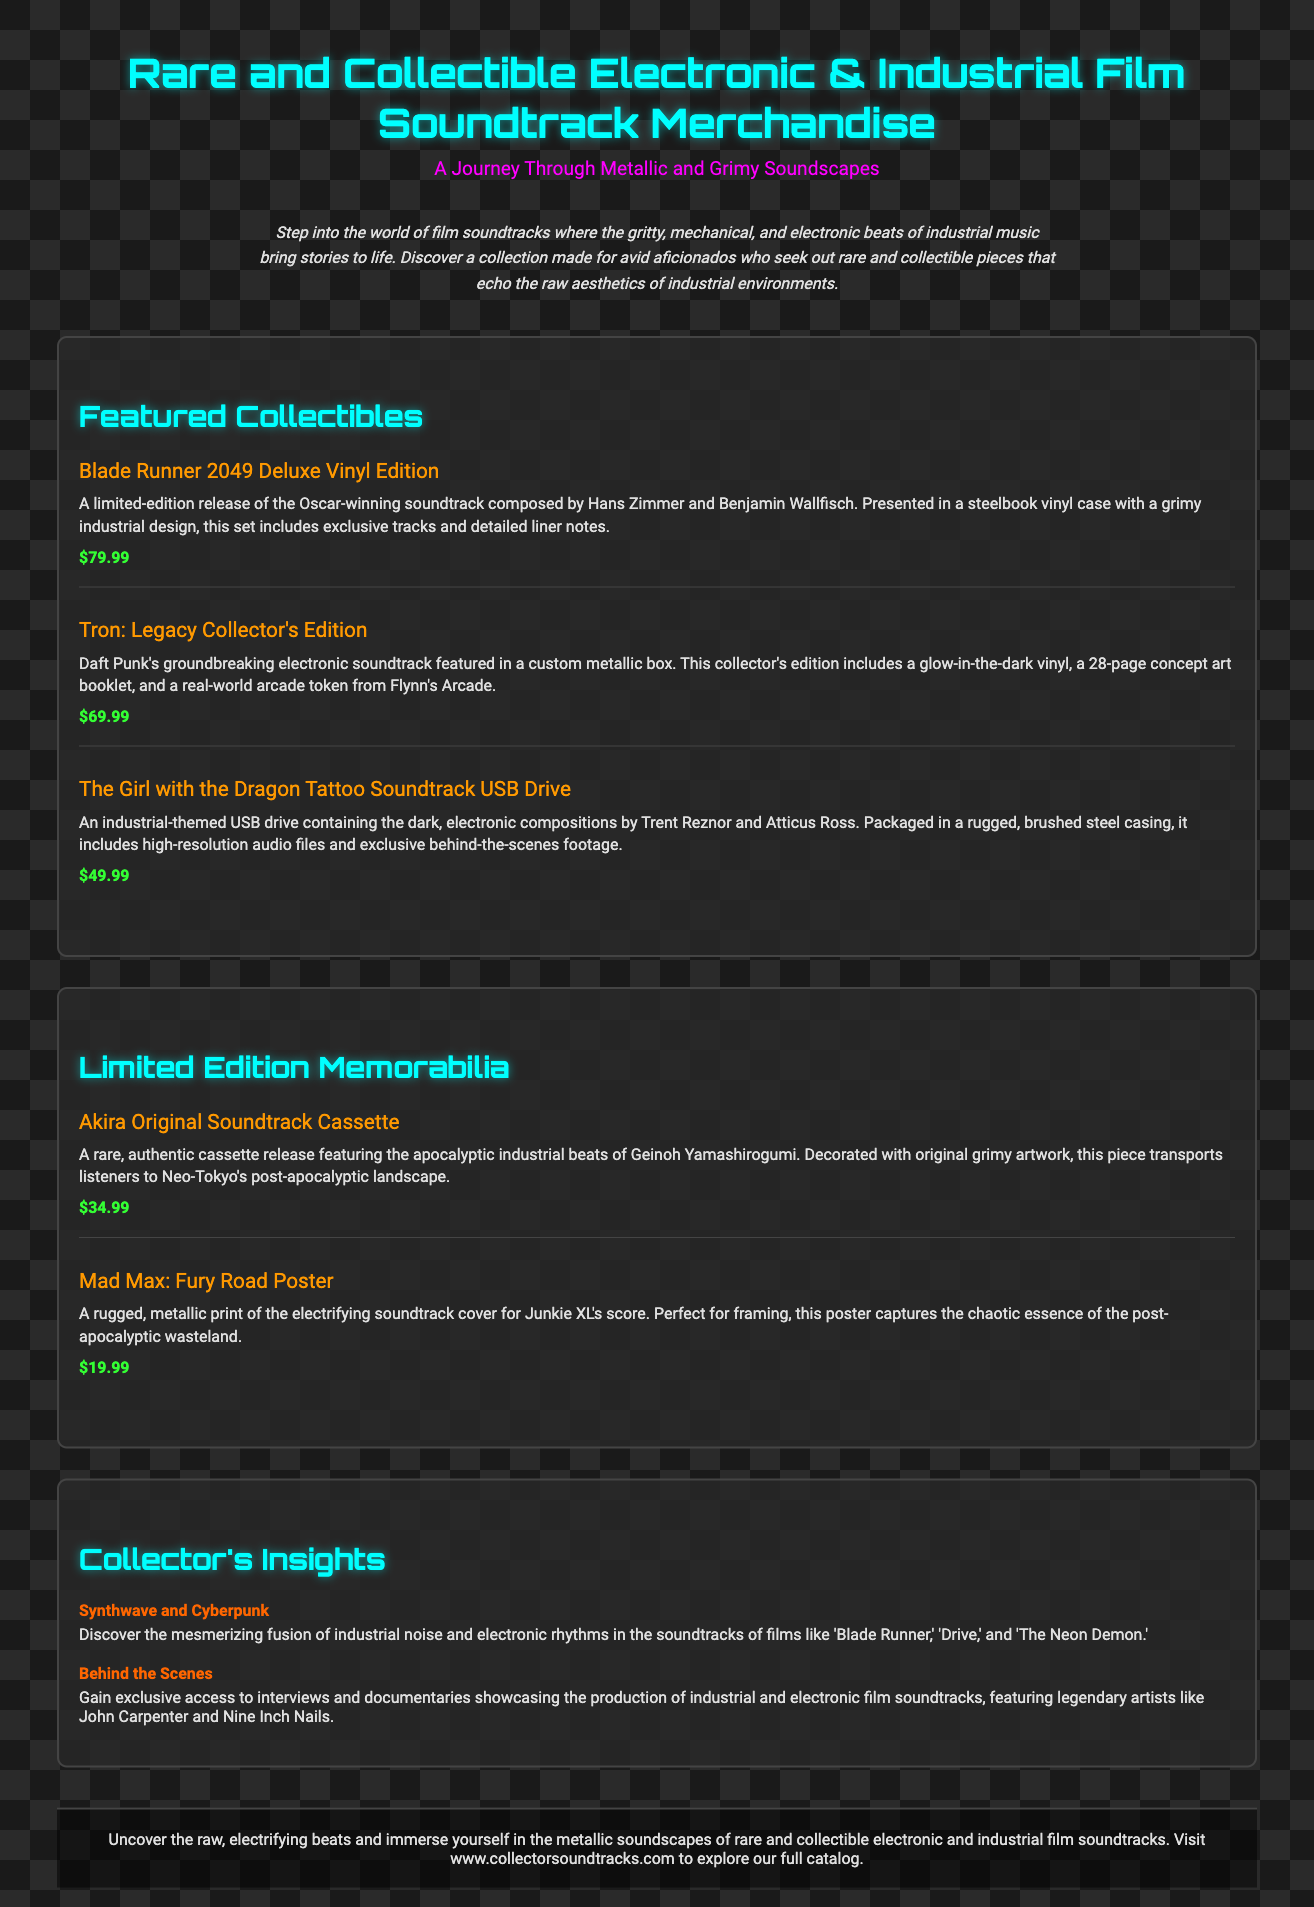what is the title of the first item in Featured Collectibles? The title of the first item listed under Featured Collectibles is found in the item name.
Answer: Blade Runner 2049 Deluxe Vinyl Edition what is the price of The Girl with the Dragon Tattoo Soundtrack USB Drive? The price is stated directly under its description in the document.
Answer: $49.99 how many items are listed in the Limited Edition Memorabilia section? The number of items can be counted from the listings under that section.
Answer: 2 who composed the soundtrack for Tron: Legacy? The composer of the soundtrack is mentioned in the item's description.
Answer: Daft Punk what is the primary aesthetic described in this product catalog? The document emphasizes a particular style or feel throughout its text, which can be found in the introduction.
Answer: Metallic and Grimy what insight relates to Synthwave and Cyberpunk? This insight is found in the Collector's Insights section, linking specific film soundtracks to the genre.
Answer: Discover the mesmerizing fusion of industrial noise and electronic rhythms what is included in the Tron: Legacy Collector's Edition? This information is detailed in the description of that item, listing its components.
Answer: Glow-in-the-dark vinyl, 28-page concept art booklet, arcade token how many exclusive tracks does the Blade Runner 2049 Deluxe Vinyl Edition include? The document specifies the inclusion of exclusive tracks in the description of the item.
Answer: Not specified what type of packaging does The Girl with the Dragon Tattoo Soundtrack USB Drive have? The type of packaging is indicated in the USB Drive's description.
Answer: Rugged, brushed steel casing 